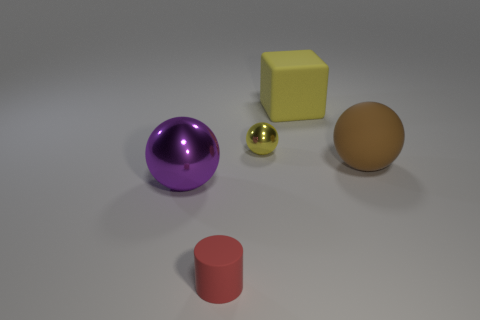Subtract all purple balls. How many balls are left? 2 Add 2 red metallic blocks. How many objects exist? 7 Subtract 0 green spheres. How many objects are left? 5 Subtract all spheres. How many objects are left? 2 Subtract 1 balls. How many balls are left? 2 Subtract all gray balls. Subtract all gray cylinders. How many balls are left? 3 Subtract all blue cylinders. How many brown spheres are left? 1 Subtract all big blocks. Subtract all large yellow rubber cylinders. How many objects are left? 4 Add 2 small red rubber cylinders. How many small red rubber cylinders are left? 3 Add 3 tiny spheres. How many tiny spheres exist? 4 